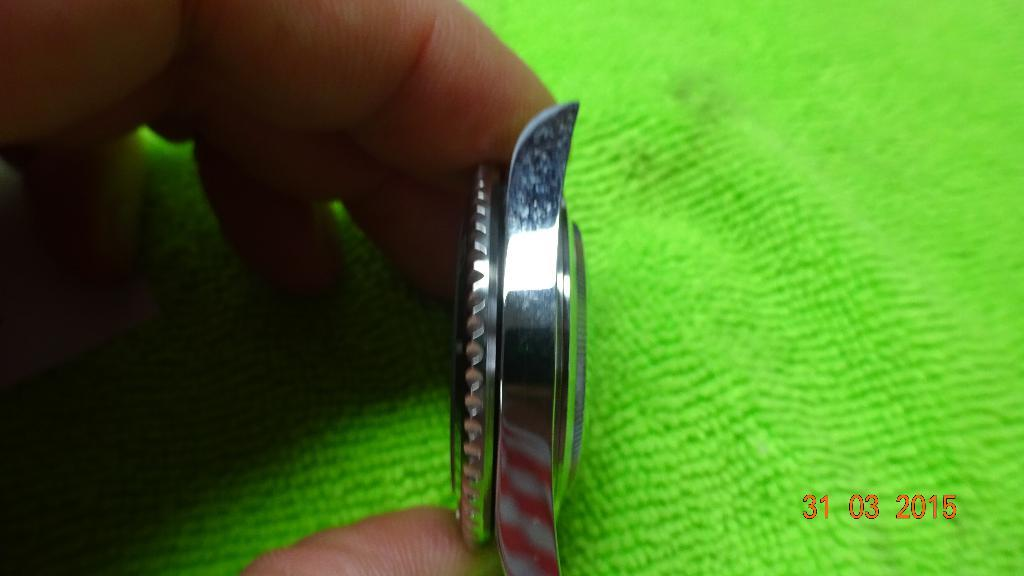<image>
Create a compact narrative representing the image presented. A watch on its side, the photo was taken in 2015. 